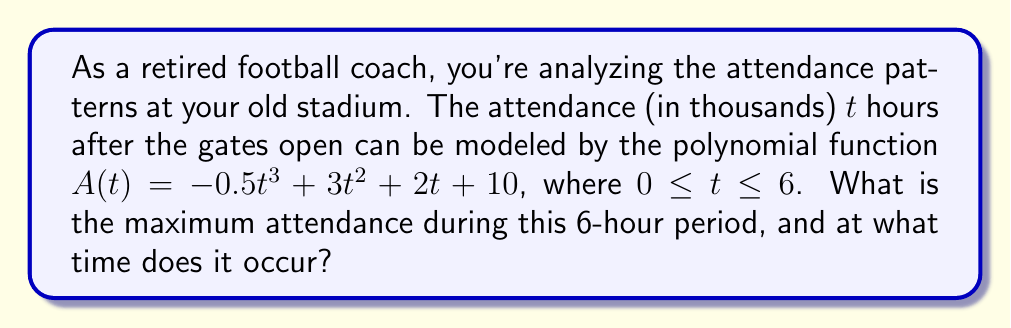Could you help me with this problem? To find the maximum attendance and when it occurs, we need to follow these steps:

1) First, we need to find the derivative of the attendance function $A(t)$:
   $$A'(t) = -1.5t^2 + 6t + 2$$

2) To find the critical points, we set $A'(t) = 0$ and solve:
   $$-1.5t^2 + 6t + 2 = 0$$
   
   This is a quadratic equation. We can solve it using the quadratic formula:
   $$t = \frac{-b \pm \sqrt{b^2 - 4ac}}{2a}$$
   
   Where $a = -1.5$, $b = 6$, and $c = 2$

3) Plugging in these values:
   $$t = \frac{-6 \pm \sqrt{36 - 4(-1.5)(2)}}{2(-1.5)}$$
   $$t = \frac{-6 \pm \sqrt{48}}{-3} = \frac{-6 \pm 4\sqrt{3}}{-3}$$

4) This gives us two critical points:
   $$t_1 = \frac{-6 + 4\sqrt{3}}{-3} \approx 4.31$$
   $$t_2 = \frac{-6 - 4\sqrt{3}}{-3} \approx -0.31$$

5) Since $t_2$ is negative and outside our domain, we only consider $t_1 \approx 4.31$.

6) To confirm this is a maximum, we can check the second derivative:
   $$A''(t) = -3t + 6$$
   $$A''(4.31) \approx -6.93 < 0$$
   
   Since $A''(4.31) < 0$, this confirms that $t = 4.31$ gives a maximum.

7) To find the maximum attendance, we plug $t = 4.31$ into our original function:
   $$A(4.31) = -0.5(4.31)^3 + 3(4.31)^2 + 2(4.31) + 10 \approx 34.35$$

Therefore, the maximum attendance is approximately 34,350 people, occurring about 4.31 hours after the gates open.
Answer: The maximum attendance is approximately 34,350 people, occurring about 4.31 hours after the gates open. 